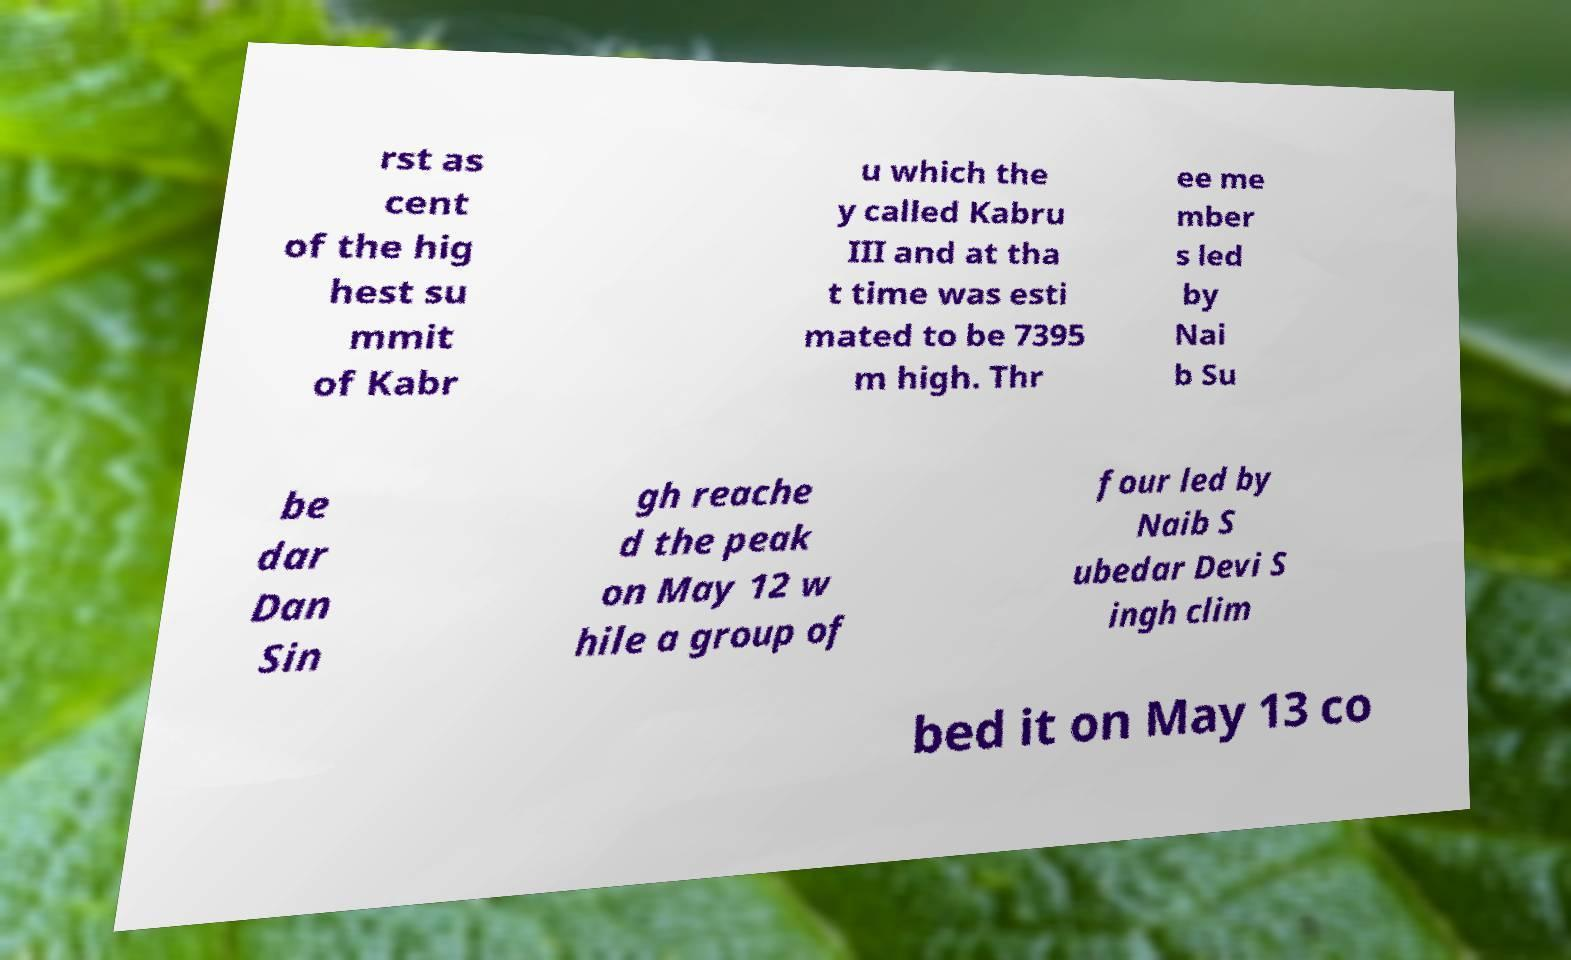Could you assist in decoding the text presented in this image and type it out clearly? rst as cent of the hig hest su mmit of Kabr u which the y called Kabru III and at tha t time was esti mated to be 7395 m high. Thr ee me mber s led by Nai b Su be dar Dan Sin gh reache d the peak on May 12 w hile a group of four led by Naib S ubedar Devi S ingh clim bed it on May 13 co 